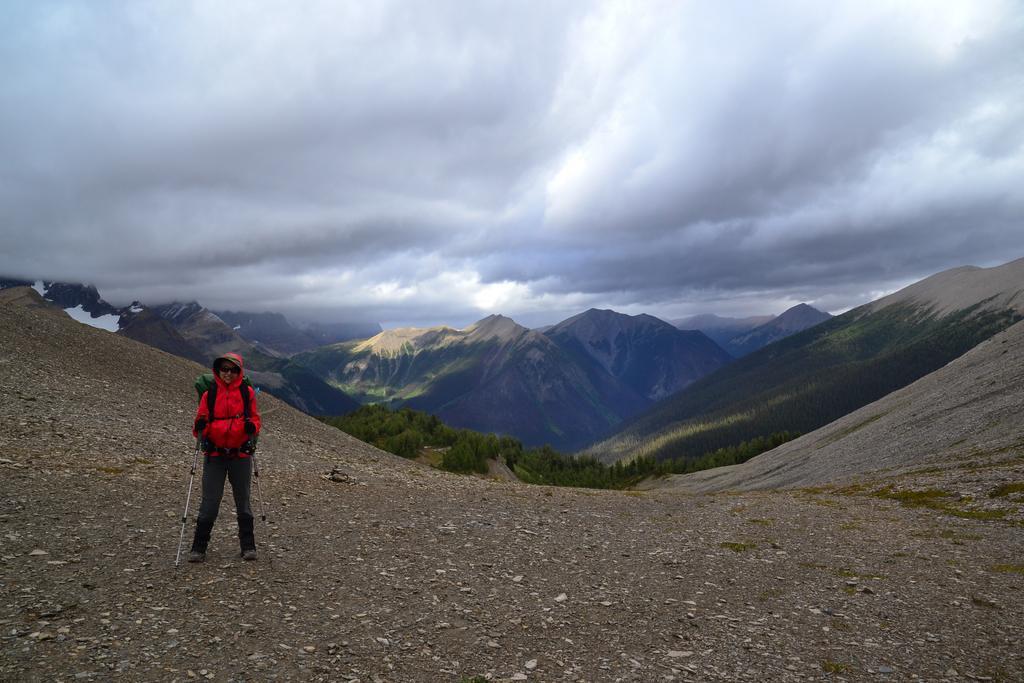Describe this image in one or two sentences. In this image, we can see a person is standing, wearing a backpack and goggles and holding sticks. Background we can see few mountains, trees and cloudy sky. 